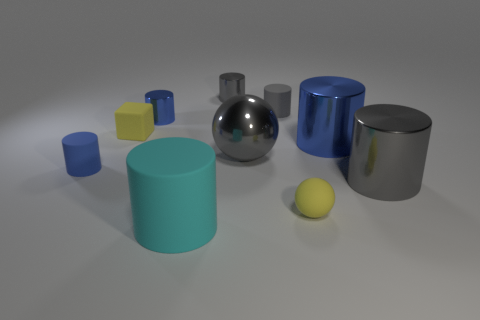Subtract all cyan balls. How many blue cylinders are left? 3 Subtract all big gray cylinders. How many cylinders are left? 6 Subtract all gray cylinders. How many cylinders are left? 4 Subtract all gray cylinders. Subtract all red blocks. How many cylinders are left? 4 Subtract all blocks. How many objects are left? 9 Subtract all large blue metal objects. Subtract all small gray rubber objects. How many objects are left? 8 Add 1 tiny gray matte cylinders. How many tiny gray matte cylinders are left? 2 Add 4 balls. How many balls exist? 6 Subtract 0 cyan spheres. How many objects are left? 10 